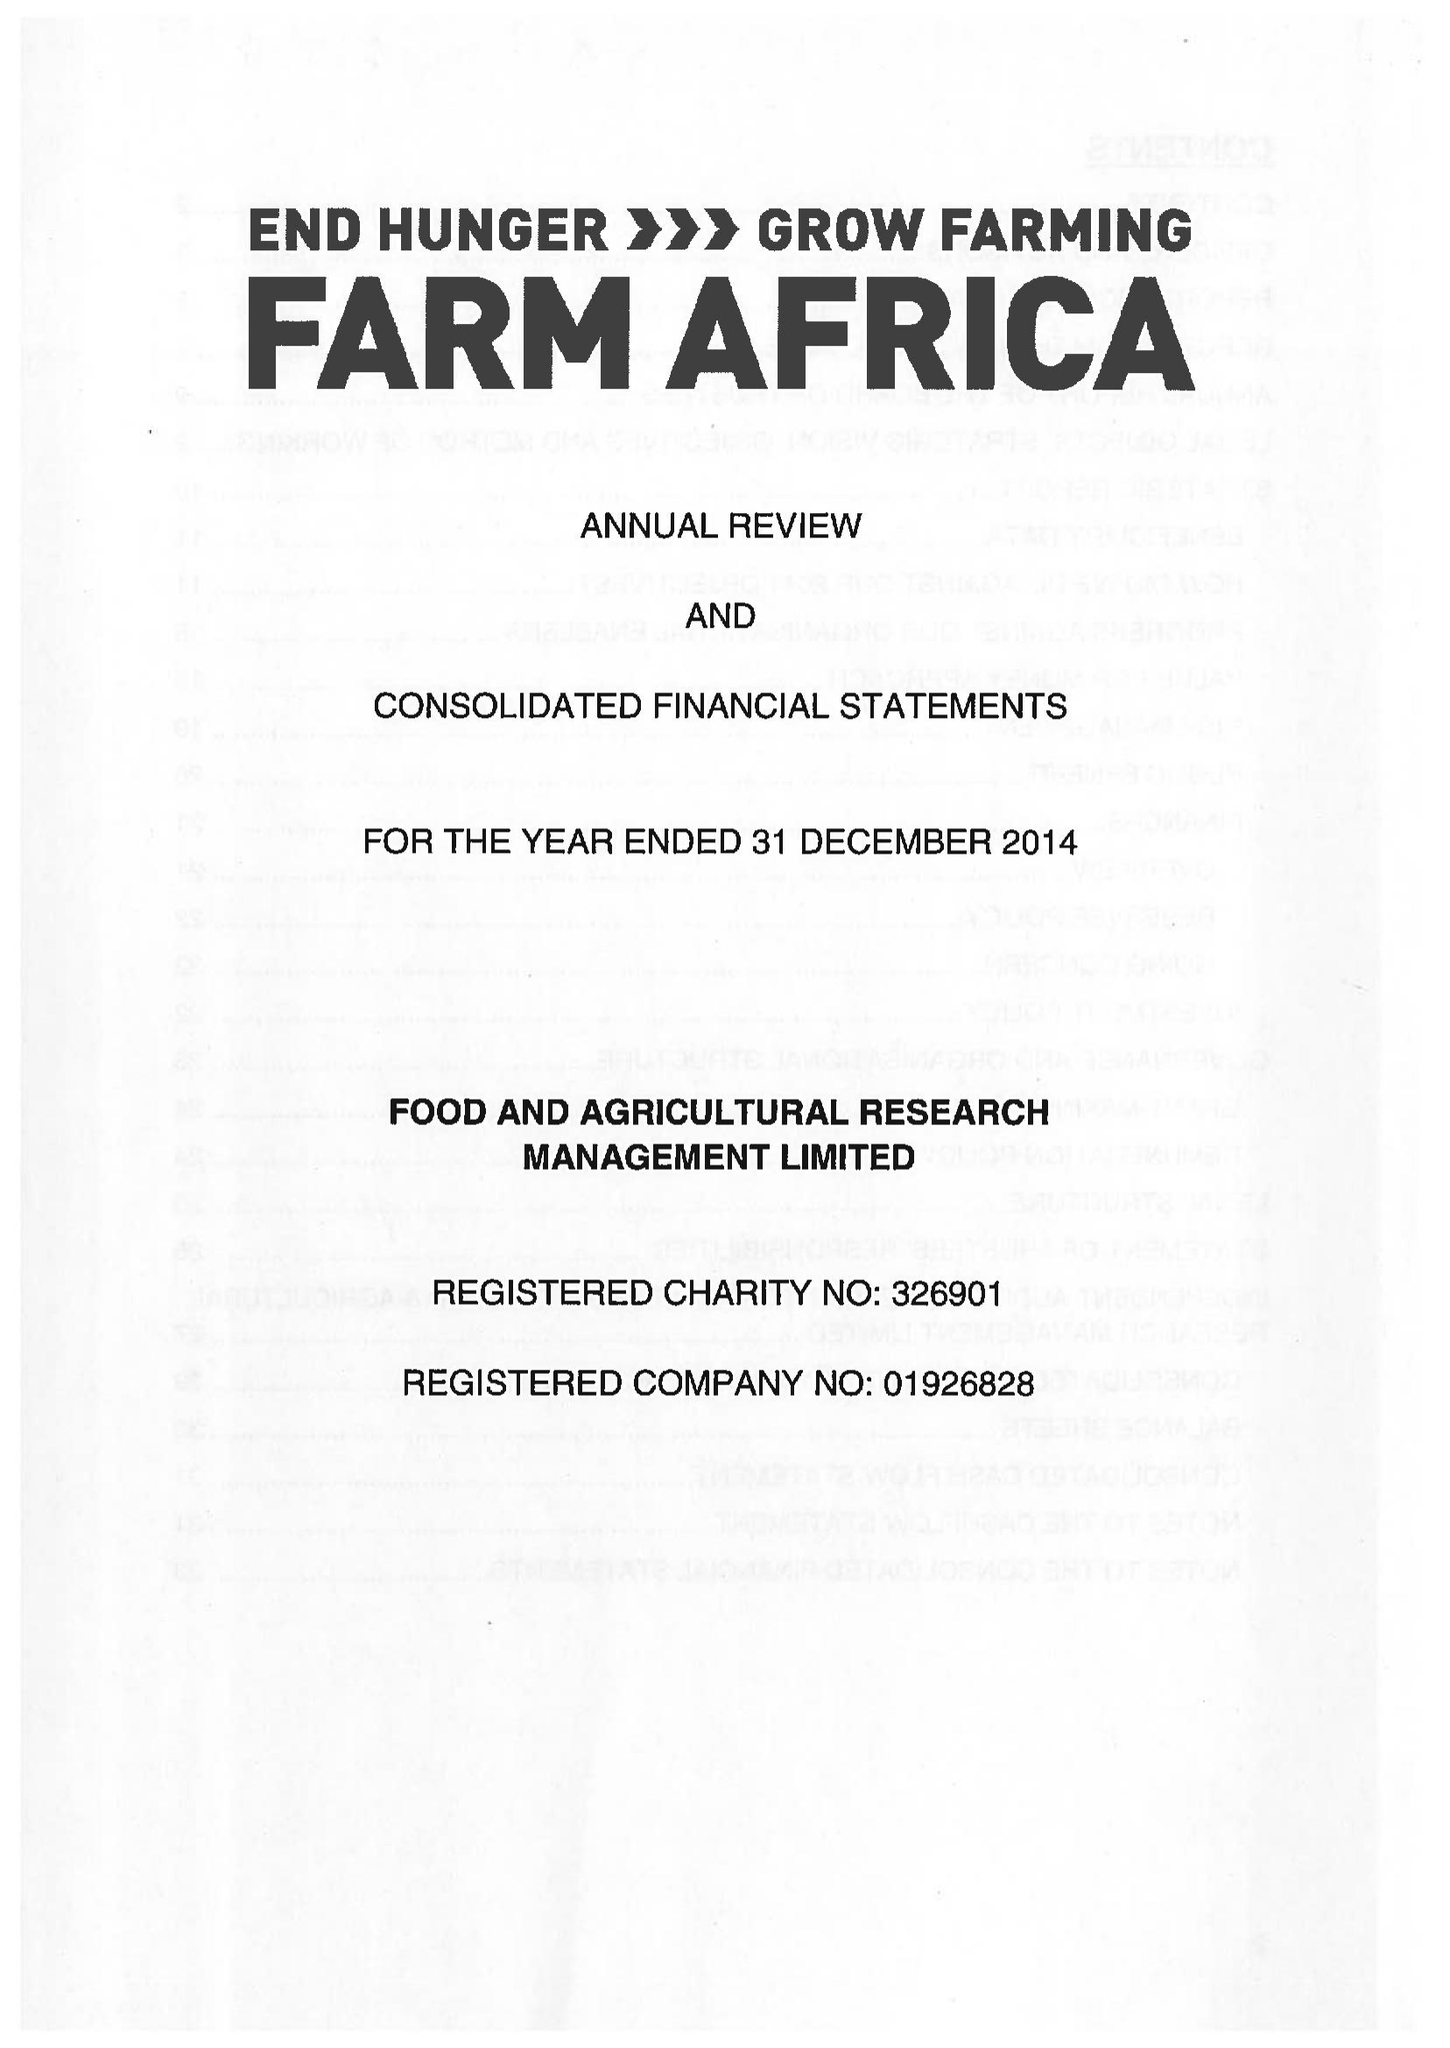What is the value for the charity_number?
Answer the question using a single word or phrase. 326901 